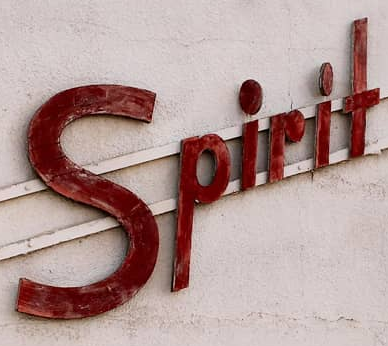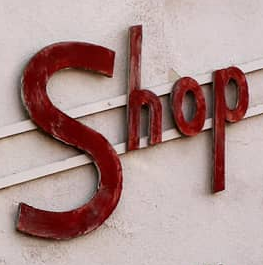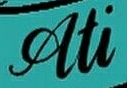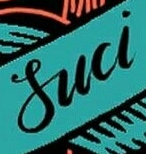What text is displayed in these images sequentially, separated by a semicolon? Spirit; Shop; Ati; Suci 